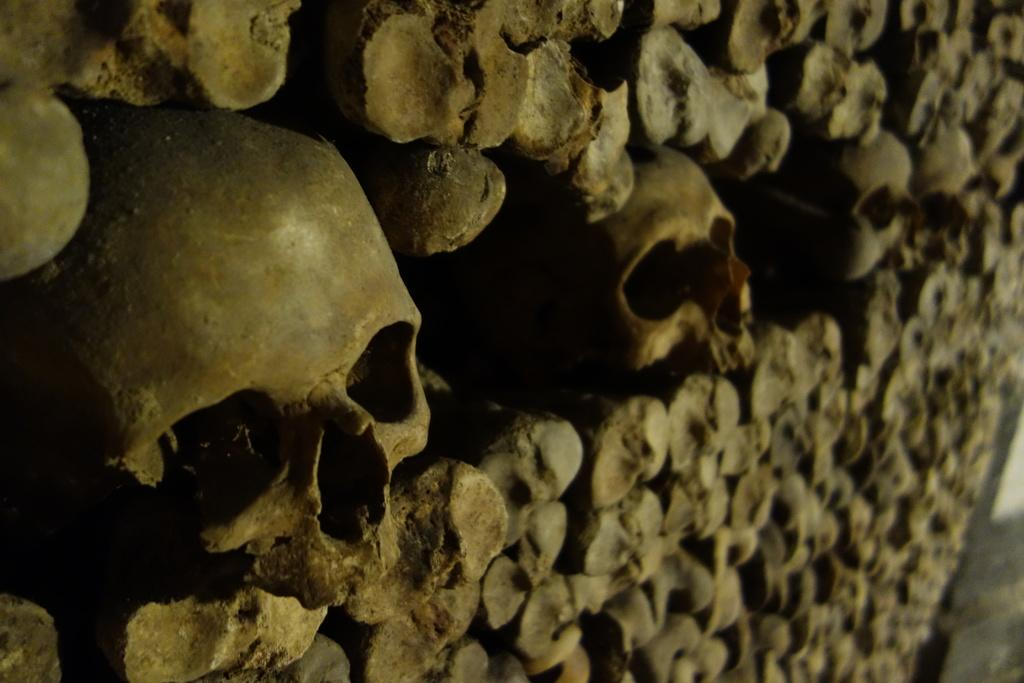What is the main subject in the center of the image? There is a wall in the center of the image. What is the wall made up of? The wall is made up of human skulls and bones. What type of act is being performed by the kettle in the image? There is no kettle present in the image, so no act can be performed by it. 